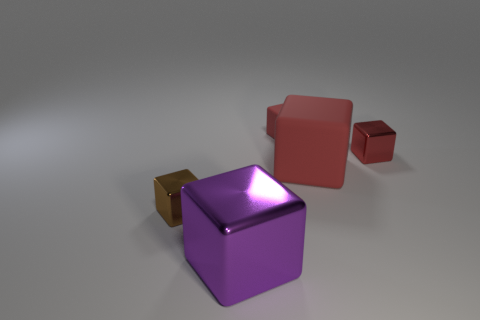There is a matte block that is the same color as the small matte object; what size is it?
Provide a succinct answer. Large. There is a tiny metallic object that is the same color as the big matte object; what shape is it?
Your answer should be very brief. Cube. Do the large red object and the small metallic thing that is behind the brown thing have the same shape?
Your answer should be compact. Yes. The small red thing that is in front of the small red thing that is behind the tiny red shiny cube behind the purple shiny thing is made of what material?
Your response must be concise. Metal. How many other objects are there of the same size as the brown metallic cube?
Your answer should be very brief. 2. Does the small matte cube have the same color as the large matte block?
Ensure brevity in your answer.  Yes. There is a big object left of the big red thing that is to the right of the big shiny thing; what number of tiny things are on the right side of it?
Your response must be concise. 2. There is a thing in front of the cube that is to the left of the purple block; what is its material?
Your response must be concise. Metal. Is there a large red rubber thing of the same shape as the small brown metal object?
Offer a terse response. Yes. There is another metal cube that is the same size as the red shiny block; what is its color?
Keep it short and to the point. Brown. 